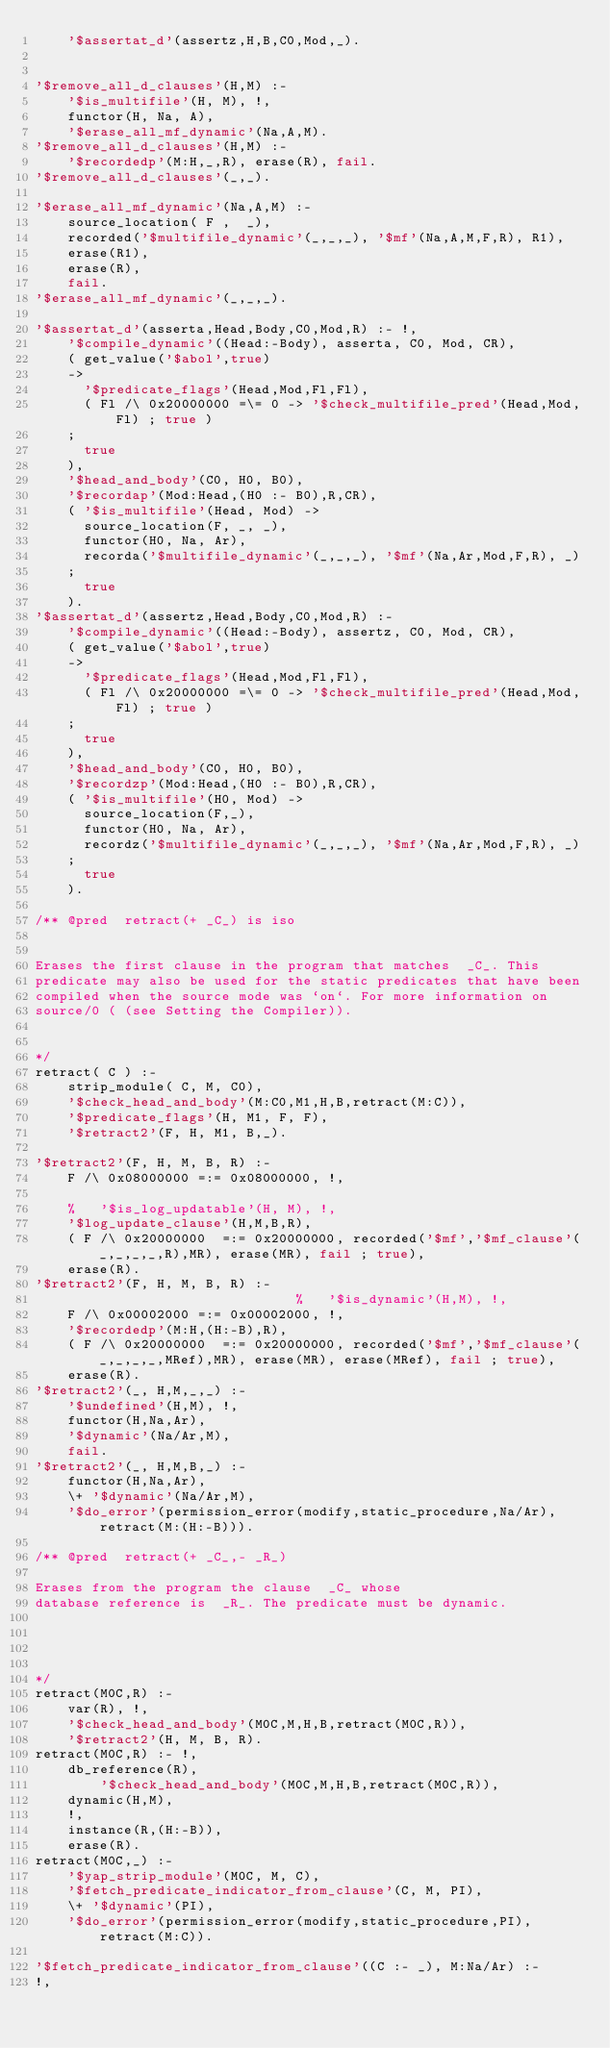Convert code to text. <code><loc_0><loc_0><loc_500><loc_500><_Prolog_>	'$assertat_d'(assertz,H,B,C0,Mod,_).


'$remove_all_d_clauses'(H,M) :-
	'$is_multifile'(H, M), !,
	functor(H, Na, A),
	'$erase_all_mf_dynamic'(Na,A,M).
'$remove_all_d_clauses'(H,M) :-
	'$recordedp'(M:H,_,R), erase(R), fail.
'$remove_all_d_clauses'(_,_).

'$erase_all_mf_dynamic'(Na,A,M) :-
	source_location( F ,  _),
	recorded('$multifile_dynamic'(_,_,_), '$mf'(Na,A,M,F,R), R1),
	erase(R1),
	erase(R),
	fail.
'$erase_all_mf_dynamic'(_,_,_).

'$assertat_d'(asserta,Head,Body,C0,Mod,R) :- !,
	'$compile_dynamic'((Head:-Body), asserta, C0, Mod, CR),
    ( get_value('$abol',true)
    ->
      '$predicate_flags'(Head,Mod,Fl,Fl),
      ( Fl /\ 0x20000000 =\= 0 -> '$check_multifile_pred'(Head,Mod,Fl) ; true )
    ;
      true
    ),
	'$head_and_body'(C0, H0, B0),
	'$recordap'(Mod:Head,(H0 :- B0),R,CR),
	( '$is_multifile'(Head, Mod) ->
      source_location(F, _, _),
      functor(H0, Na, Ar),
      recorda('$multifile_dynamic'(_,_,_), '$mf'(Na,Ar,Mod,F,R), _)
	;
      true
	).
'$assertat_d'(assertz,Head,Body,C0,Mod,R) :-
	'$compile_dynamic'((Head:-Body), assertz, C0, Mod, CR),
    ( get_value('$abol',true)
    ->
      '$predicate_flags'(Head,Mod,Fl,Fl),
      ( Fl /\ 0x20000000 =\= 0 -> '$check_multifile_pred'(Head,Mod,Fl) ; true )
    ;
      true
    ),
	'$head_and_body'(C0, H0, B0),
	'$recordzp'(Mod:Head,(H0 :- B0),R,CR),
	( '$is_multifile'(H0, Mod) ->
      source_location(F,_),
      functor(H0, Na, Ar),
      recordz('$multifile_dynamic'(_,_,_), '$mf'(Na,Ar,Mod,F,R), _)
	;
      true
	).

/** @pred  retract(+ _C_) is iso


Erases the first clause in the program that matches  _C_. This
predicate may also be used for the static predicates that have been
compiled when the source mode was `on`. For more information on
source/0 ( (see Setting the Compiler)).


*/
retract( C ) :-
    strip_module( C, M, C0),
    '$check_head_and_body'(M:C0,M1,H,B,retract(M:C)),
    '$predicate_flags'(H, M1, F, F),
    '$retract2'(F, H, M1, B,_).

'$retract2'(F, H, M, B, R) :-
	F /\ 0x08000000 =:= 0x08000000, !,

	%	'$is_log_updatable'(H, M), !,
	'$log_update_clause'(H,M,B,R),
	( F /\ 0x20000000  =:= 0x20000000, recorded('$mf','$mf_clause'(_,_,_,_,R),MR), erase(MR), fail ; true),
	erase(R).
'$retract2'(F, H, M, B, R) :-
                                %	'$is_dynamic'(H,M), !,
	F /\ 0x00002000 =:= 0x00002000, !,
	'$recordedp'(M:H,(H:-B),R),
	( F /\ 0x20000000  =:= 0x20000000, recorded('$mf','$mf_clause'(_,_,_,_,MRef),MR), erase(MR), erase(MRef), fail ; true),
	erase(R).
'$retract2'(_, H,M,_,_) :-
	'$undefined'(H,M), !,
	functor(H,Na,Ar),
	'$dynamic'(Na/Ar,M),
	fail.
'$retract2'(_, H,M,B,_) :-
	functor(H,Na,Ar),
	\+ '$dynamic'(Na/Ar,M),
	'$do_error'(permission_error(modify,static_procedure,Na/Ar),retract(M:(H:-B))).

/** @pred  retract(+ _C_,- _R_)

Erases from the program the clause  _C_ whose
database reference is  _R_. The predicate must be dynamic.




*/
retract(M0C,R) :-
	var(R), !,
	'$check_head_and_body'(M0C,M,H,B,retract(M0C,R)),
	'$retract2'(H, M, B, R).
retract(M0C,R) :- !,
	db_reference(R),
    	'$check_head_and_body'(M0C,M,H,B,retract(M0C,R)),
	dynamic(H,M),
	!,
	instance(R,(H:-B)),
	erase(R).
retract(M0C,_) :-
    '$yap_strip_module'(M0C, M, C),
    '$fetch_predicate_indicator_from_clause'(C, M, PI),
    \+ '$dynamic'(PI),
    '$do_error'(permission_error(modify,static_procedure,PI),retract(M:C)).

'$fetch_predicate_indicator_from_clause'((C :- _), M:Na/Ar) :-
!,</code> 